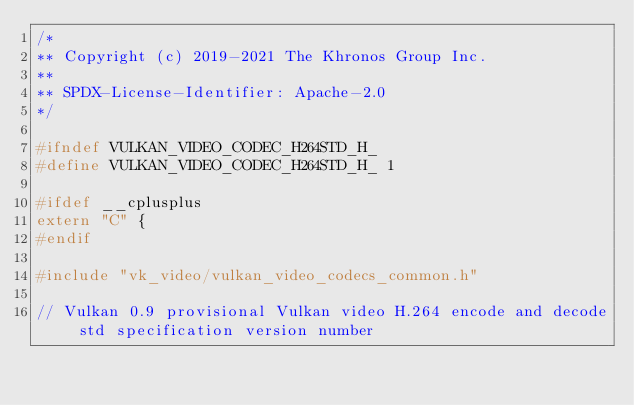Convert code to text. <code><loc_0><loc_0><loc_500><loc_500><_C_>/*
** Copyright (c) 2019-2021 The Khronos Group Inc.
**
** SPDX-License-Identifier: Apache-2.0
*/

#ifndef VULKAN_VIDEO_CODEC_H264STD_H_
#define VULKAN_VIDEO_CODEC_H264STD_H_ 1

#ifdef __cplusplus
extern "C" {
#endif

#include "vk_video/vulkan_video_codecs_common.h"

// Vulkan 0.9 provisional Vulkan video H.264 encode and decode std specification version number</code> 